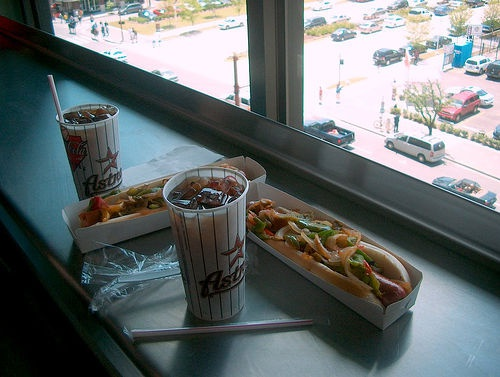Describe the objects in this image and their specific colors. I can see cup in black, gray, maroon, and darkgray tones, hot dog in black, maroon, olive, and gray tones, car in black, white, tan, darkgray, and gray tones, cup in black, gray, and darkgray tones, and hot dog in black, maroon, and gray tones in this image. 